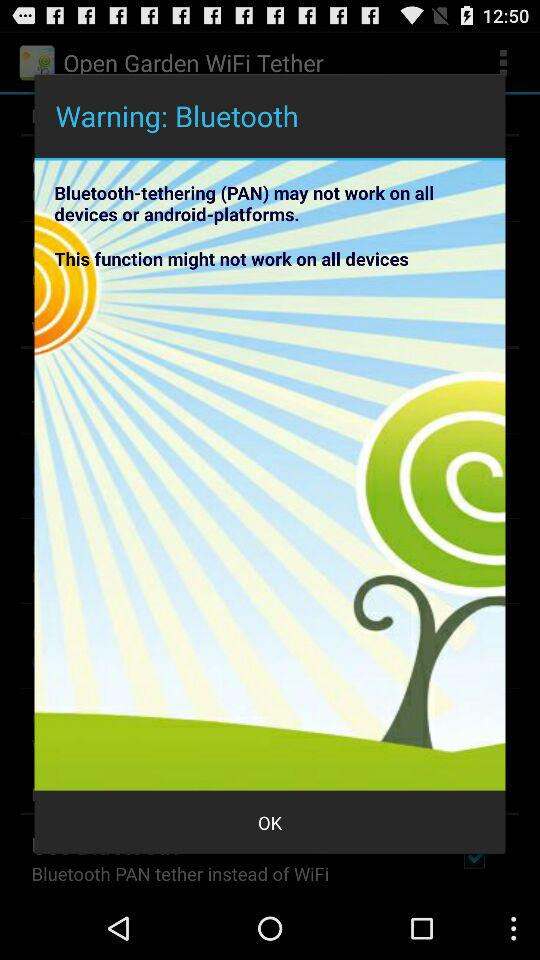How many lines of text are there in the warning message?
Answer the question using a single word or phrase. 2 